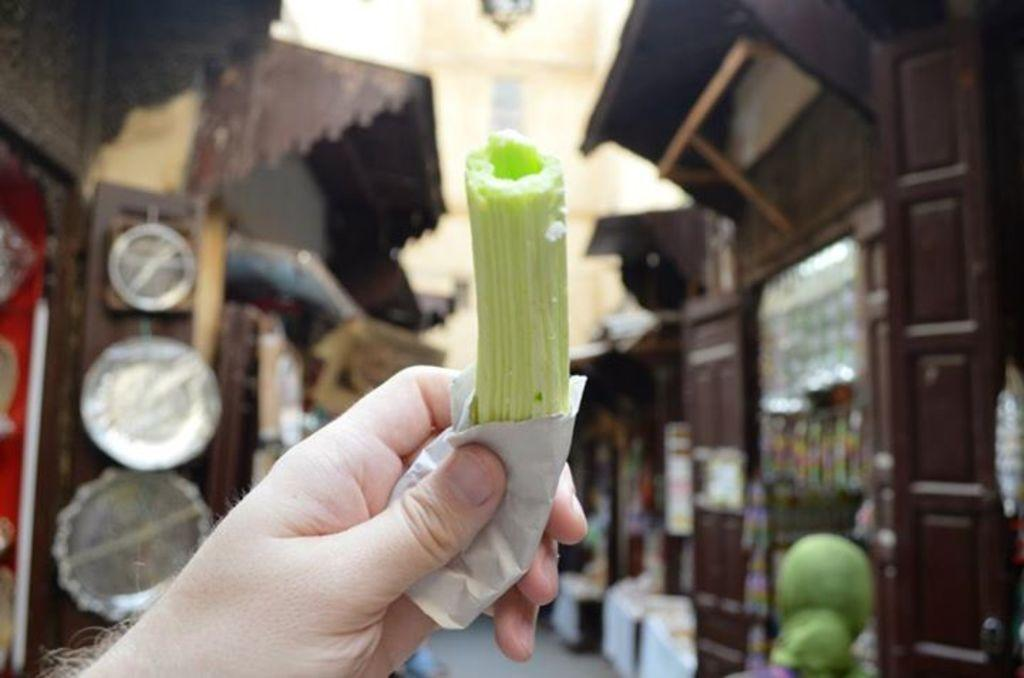What is the hand holding in the image? The fact provided does not specify what the object is, so we cannot definitively answer this question. What can be seen in the background of the image? There are houses with stores in the background of the image. What type of drain is visible in the image? There is no drain present in the image. What kind of sheet is being used to support the hand in the image? There is no sheet present in the image, and the hand is not being supported by any object. 